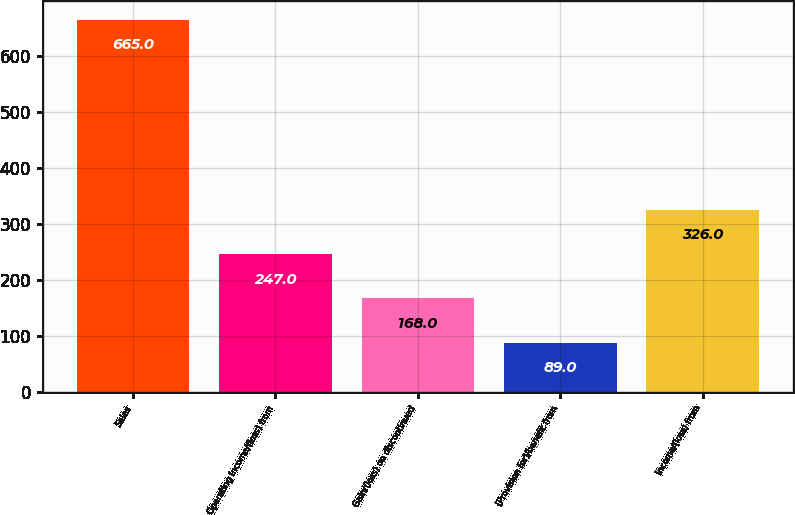Convert chart to OTSL. <chart><loc_0><loc_0><loc_500><loc_500><bar_chart><fcel>Sales<fcel>Operating income/(loss) from<fcel>Gain/(loss) on discontinued<fcel>(Provision for)/benefit from<fcel>Income/(loss) from<nl><fcel>665<fcel>247<fcel>168<fcel>89<fcel>326<nl></chart> 